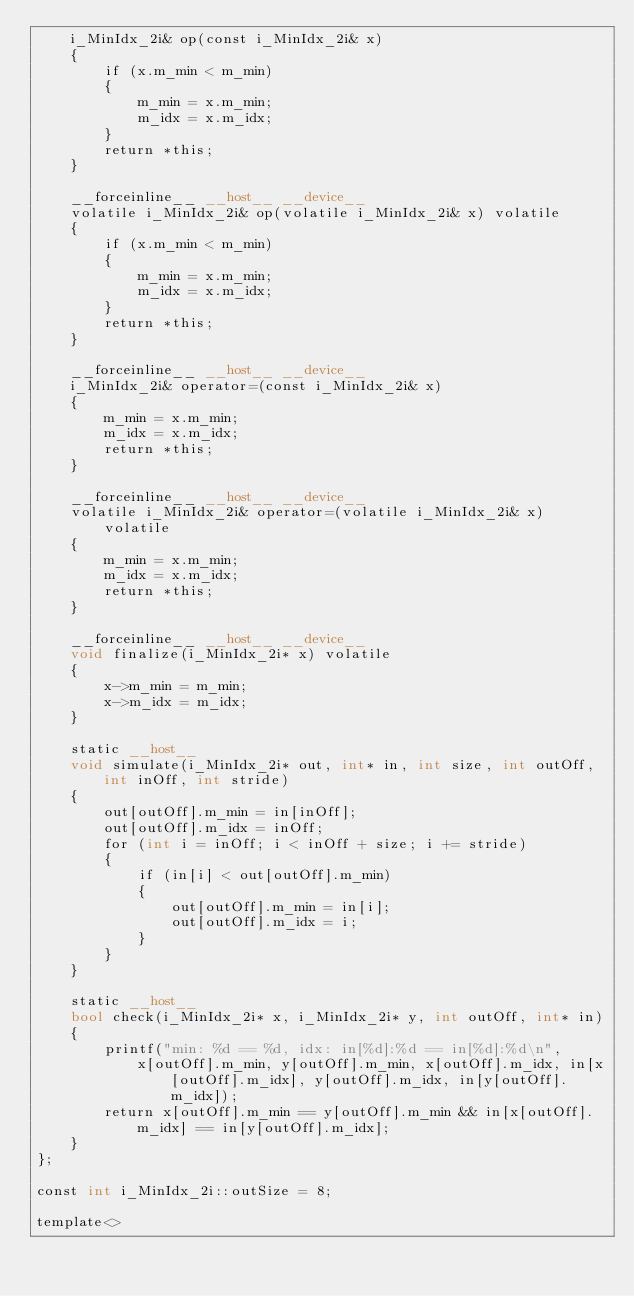<code> <loc_0><loc_0><loc_500><loc_500><_Cuda_>    i_MinIdx_2i& op(const i_MinIdx_2i& x)
    {
        if (x.m_min < m_min)
        {
            m_min = x.m_min;
            m_idx = x.m_idx;
        }
        return *this;
    }

    __forceinline__ __host__ __device__
    volatile i_MinIdx_2i& op(volatile i_MinIdx_2i& x) volatile
    {
        if (x.m_min < m_min)
        {
            m_min = x.m_min;
            m_idx = x.m_idx;
        }
        return *this;
    }

    __forceinline__ __host__ __device__
    i_MinIdx_2i& operator=(const i_MinIdx_2i& x)
    {
        m_min = x.m_min;
        m_idx = x.m_idx;
        return *this;
    }

    __forceinline__ __host__ __device__
    volatile i_MinIdx_2i& operator=(volatile i_MinIdx_2i& x) volatile
    {
        m_min = x.m_min;
        m_idx = x.m_idx;
        return *this;
    }

    __forceinline__ __host__ __device__
    void finalize(i_MinIdx_2i* x) volatile
    {
        x->m_min = m_min;
        x->m_idx = m_idx;
    }

    static __host__
    void simulate(i_MinIdx_2i* out, int* in, int size, int outOff, int inOff, int stride)
    {
        out[outOff].m_min = in[inOff];
        out[outOff].m_idx = inOff;
        for (int i = inOff; i < inOff + size; i += stride)
        {
            if (in[i] < out[outOff].m_min)
            {
                out[outOff].m_min = in[i];
                out[outOff].m_idx = i;
            }
        }
    }

    static __host__
    bool check(i_MinIdx_2i* x, i_MinIdx_2i* y, int outOff, int* in)
    {
        printf("min: %d == %d, idx: in[%d]:%d == in[%d]:%d\n",
            x[outOff].m_min, y[outOff].m_min, x[outOff].m_idx, in[x[outOff].m_idx], y[outOff].m_idx, in[y[outOff].m_idx]);
        return x[outOff].m_min == y[outOff].m_min && in[x[outOff].m_idx] == in[y[outOff].m_idx];
    }
};

const int i_MinIdx_2i::outSize = 8;

template<></code> 